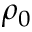Convert formula to latex. <formula><loc_0><loc_0><loc_500><loc_500>\rho _ { 0 }</formula> 